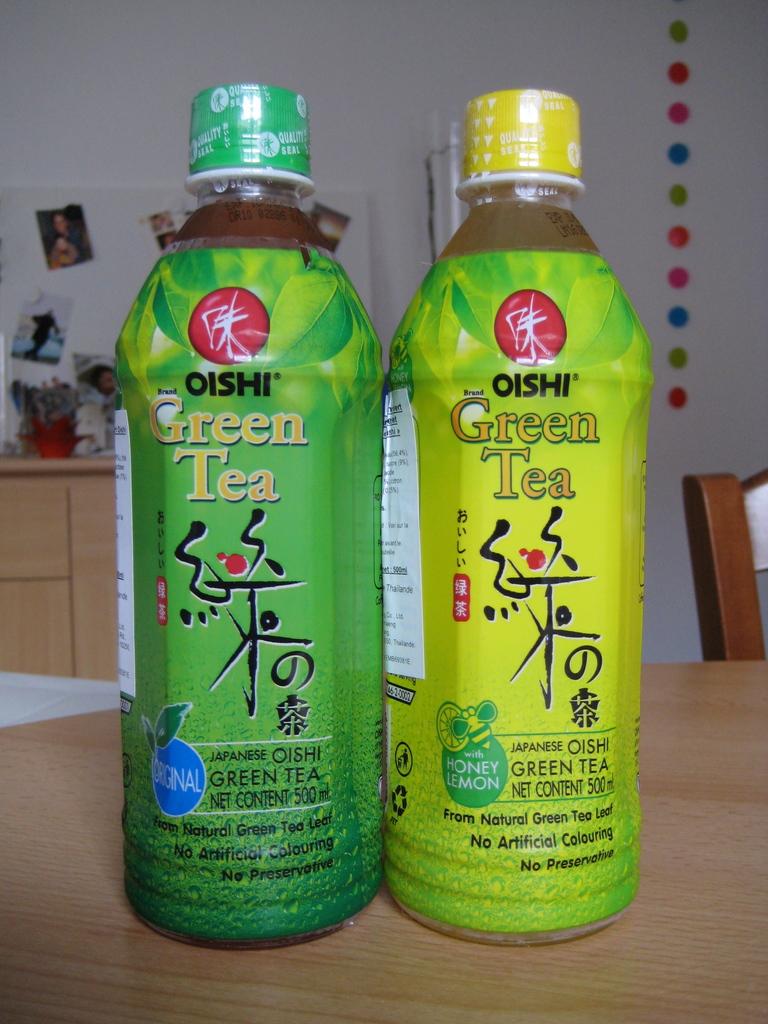What kind of drinks are those?
Give a very brief answer. Green tea. What is the brand?
Give a very brief answer. Oishi. 